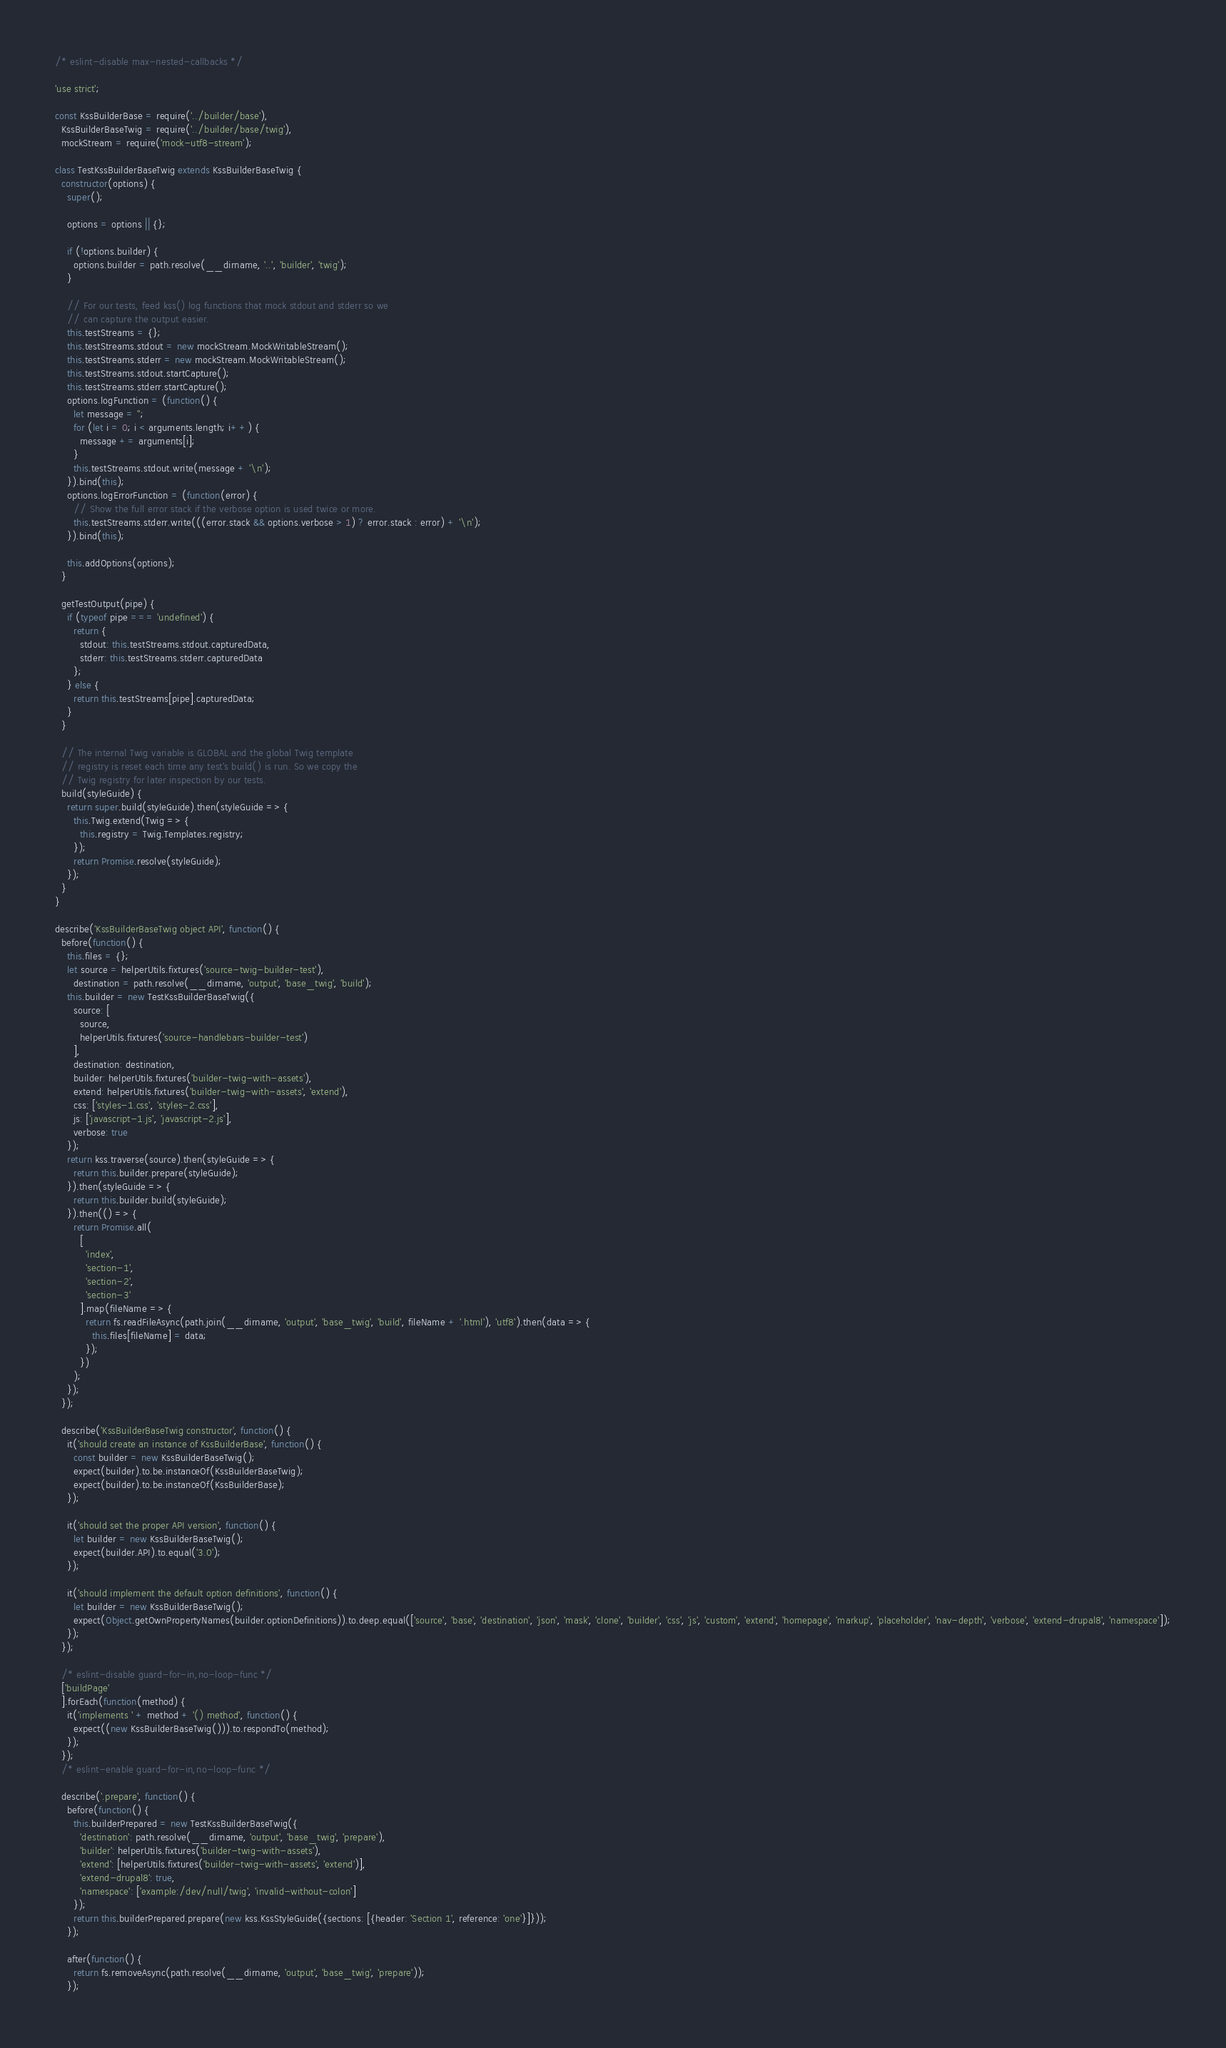<code> <loc_0><loc_0><loc_500><loc_500><_JavaScript_>/* eslint-disable max-nested-callbacks */

'use strict';

const KssBuilderBase = require('../builder/base'),
  KssBuilderBaseTwig = require('../builder/base/twig'),
  mockStream = require('mock-utf8-stream');

class TestKssBuilderBaseTwig extends KssBuilderBaseTwig {
  constructor(options) {
    super();

    options = options || {};

    if (!options.builder) {
      options.builder = path.resolve(__dirname, '..', 'builder', 'twig');
    }

    // For our tests, feed kss() log functions that mock stdout and stderr so we
    // can capture the output easier.
    this.testStreams = {};
    this.testStreams.stdout = new mockStream.MockWritableStream();
    this.testStreams.stderr = new mockStream.MockWritableStream();
    this.testStreams.stdout.startCapture();
    this.testStreams.stderr.startCapture();
    options.logFunction = (function() {
      let message = '';
      for (let i = 0; i < arguments.length; i++) {
        message += arguments[i];
      }
      this.testStreams.stdout.write(message + '\n');
    }).bind(this);
    options.logErrorFunction = (function(error) {
      // Show the full error stack if the verbose option is used twice or more.
      this.testStreams.stderr.write(((error.stack && options.verbose > 1) ? error.stack : error) + '\n');
    }).bind(this);

    this.addOptions(options);
  }

  getTestOutput(pipe) {
    if (typeof pipe === 'undefined') {
      return {
        stdout: this.testStreams.stdout.capturedData,
        stderr: this.testStreams.stderr.capturedData
      };
    } else {
      return this.testStreams[pipe].capturedData;
    }
  }

  // The internal Twig variable is GLOBAL and the global Twig template
  // registry is reset each time any test's build() is run. So we copy the
  // Twig registry for later inspection by our tests.
  build(styleGuide) {
    return super.build(styleGuide).then(styleGuide => {
      this.Twig.extend(Twig => {
        this.registry = Twig.Templates.registry;
      });
      return Promise.resolve(styleGuide);
    });
  }
}

describe('KssBuilderBaseTwig object API', function() {
  before(function() {
    this.files = {};
    let source = helperUtils.fixtures('source-twig-builder-test'),
      destination = path.resolve(__dirname, 'output', 'base_twig', 'build');
    this.builder = new TestKssBuilderBaseTwig({
      source: [
        source,
        helperUtils.fixtures('source-handlebars-builder-test')
      ],
      destination: destination,
      builder: helperUtils.fixtures('builder-twig-with-assets'),
      extend: helperUtils.fixtures('builder-twig-with-assets', 'extend'),
      css: ['styles-1.css', 'styles-2.css'],
      js: ['javascript-1.js', 'javascript-2.js'],
      verbose: true
    });
    return kss.traverse(source).then(styleGuide => {
      return this.builder.prepare(styleGuide);
    }).then(styleGuide => {
      return this.builder.build(styleGuide);
    }).then(() => {
      return Promise.all(
        [
          'index',
          'section-1',
          'section-2',
          'section-3'
        ].map(fileName => {
          return fs.readFileAsync(path.join(__dirname, 'output', 'base_twig', 'build', fileName + '.html'), 'utf8').then(data => {
            this.files[fileName] = data;
          });
        })
      );
    });
  });

  describe('KssBuilderBaseTwig constructor', function() {
    it('should create an instance of KssBuilderBase', function() {
      const builder = new KssBuilderBaseTwig();
      expect(builder).to.be.instanceOf(KssBuilderBaseTwig);
      expect(builder).to.be.instanceOf(KssBuilderBase);
    });

    it('should set the proper API version', function() {
      let builder = new KssBuilderBaseTwig();
      expect(builder.API).to.equal('3.0');
    });

    it('should implement the default option definitions', function() {
      let builder = new KssBuilderBaseTwig();
      expect(Object.getOwnPropertyNames(builder.optionDefinitions)).to.deep.equal(['source', 'base', 'destination', 'json', 'mask', 'clone', 'builder', 'css', 'js', 'custom', 'extend', 'homepage', 'markup', 'placeholder', 'nav-depth', 'verbose', 'extend-drupal8', 'namespace']);
    });
  });

  /* eslint-disable guard-for-in,no-loop-func */
  ['buildPage'
  ].forEach(function(method) {
    it('implements ' + method + '() method', function() {
      expect((new KssBuilderBaseTwig())).to.respondTo(method);
    });
  });
  /* eslint-enable guard-for-in,no-loop-func */

  describe('.prepare', function() {
    before(function() {
      this.builderPrepared = new TestKssBuilderBaseTwig({
        'destination': path.resolve(__dirname, 'output', 'base_twig', 'prepare'),
        'builder': helperUtils.fixtures('builder-twig-with-assets'),
        'extend': [helperUtils.fixtures('builder-twig-with-assets', 'extend')],
        'extend-drupal8': true,
        'namespace': ['example:/dev/null/twig', 'invalid-without-colon']
      });
      return this.builderPrepared.prepare(new kss.KssStyleGuide({sections: [{header: 'Section 1', reference: 'one'}]}));
    });

    after(function() {
      return fs.removeAsync(path.resolve(__dirname, 'output', 'base_twig', 'prepare'));
    });
</code> 